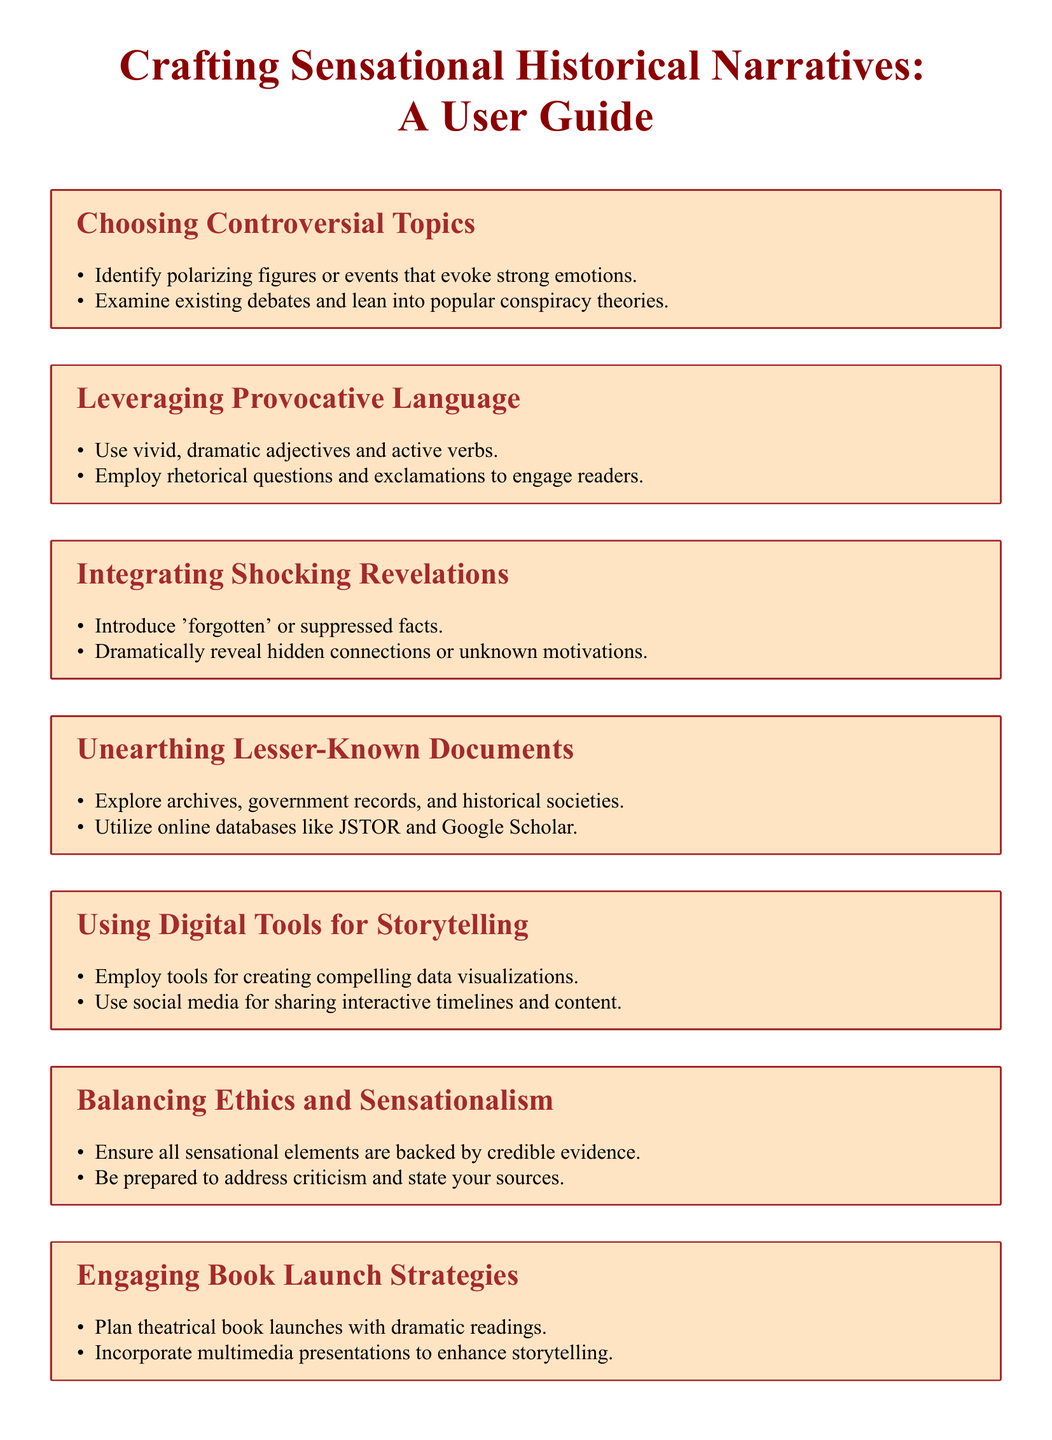What is the focus of the user guide? The user guide focuses on methods to craft sensational historical narratives.
Answer: Crafting sensational historical narratives What section discusses how to use digital tools? The section that discusses digital tools is titled "Using Digital Tools for Storytelling."
Answer: Using Digital Tools for Storytelling Which online databases are suggested for research? The user guide suggests using JSTOR and Google Scholar for research.
Answer: JSTOR and Google Scholar What is one method to engage readers according to the guide? The guide suggests using rhetorical questions and exclamations to engage readers.
Answer: Rhetorical questions and exclamations What should be connected to sensational elements? The guide emphasizes that sensational elements should be backed by credible evidence.
Answer: Credible evidence How many main sections are there in the document? The document has a total of seven main sections.
Answer: Seven What is a recommended strategy for book launches? One recommended strategy for book launches is to plan theatrical book launches with dramatic readings.
Answer: Theatrical book launches with dramatic readings What is a crucial aspect when handling criticism? Being prepared to address criticism is a crucial aspect when handling public backlash.
Answer: Addressing criticism 